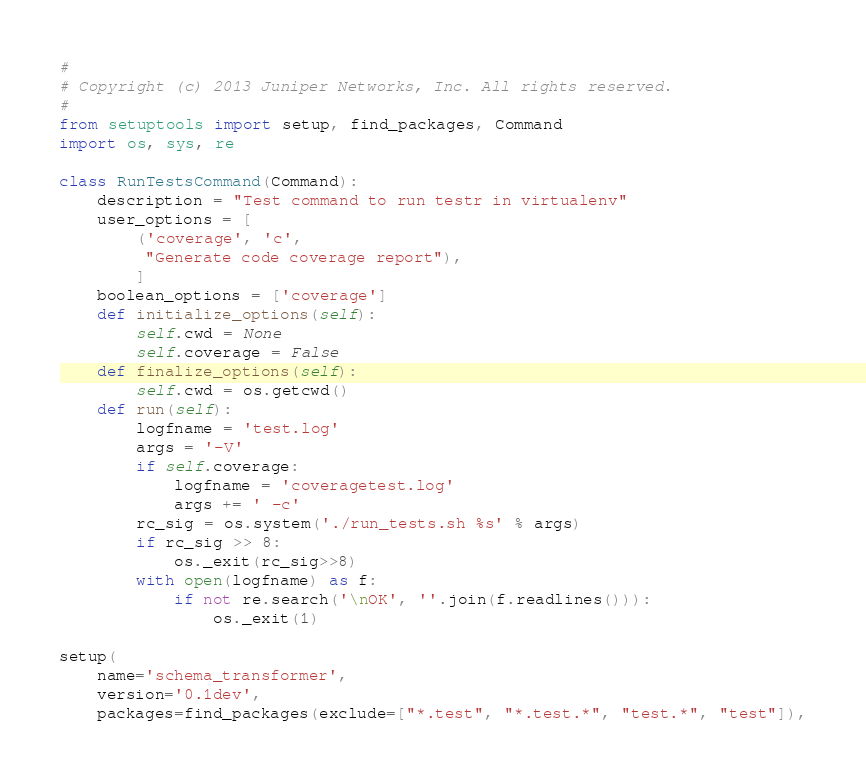<code> <loc_0><loc_0><loc_500><loc_500><_Python_>#
# Copyright (c) 2013 Juniper Networks, Inc. All rights reserved.
#
from setuptools import setup, find_packages, Command
import os, sys, re

class RunTestsCommand(Command):
    description = "Test command to run testr in virtualenv"
    user_options = [
        ('coverage', 'c',
         "Generate code coverage report"),
        ]
    boolean_options = ['coverage']
    def initialize_options(self):
        self.cwd = None
        self.coverage = False
    def finalize_options(self):
        self.cwd = os.getcwd()
    def run(self):
        logfname = 'test.log'
        args = '-V'
        if self.coverage:
            logfname = 'coveragetest.log'
            args += ' -c'
        rc_sig = os.system('./run_tests.sh %s' % args)
        if rc_sig >> 8:
            os._exit(rc_sig>>8)
        with open(logfname) as f:
            if not re.search('\nOK', ''.join(f.readlines())):
                os._exit(1)

setup(
    name='schema_transformer',
    version='0.1dev',
    packages=find_packages(exclude=["*.test", "*.test.*", "test.*", "test"]),</code> 